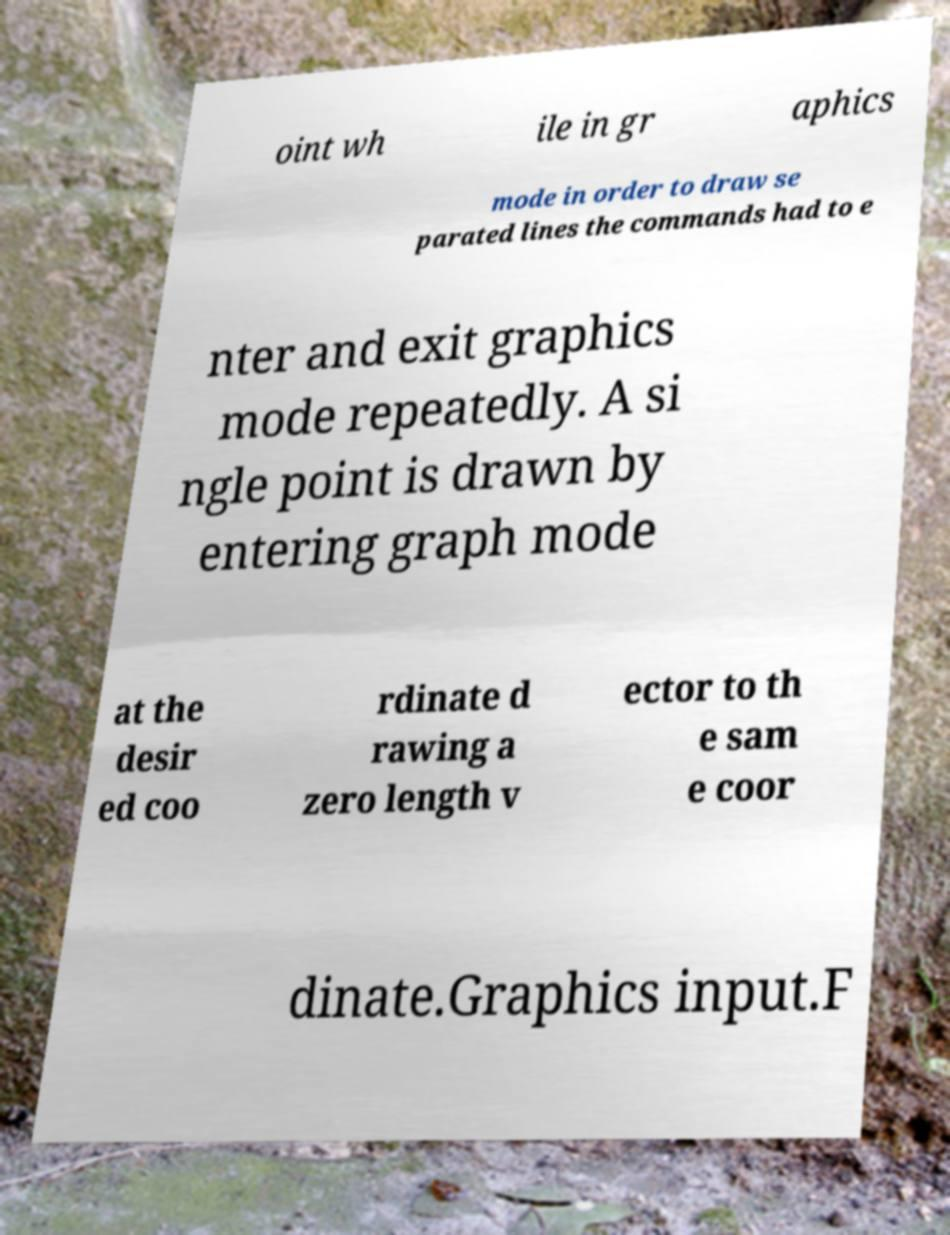I need the written content from this picture converted into text. Can you do that? oint wh ile in gr aphics mode in order to draw se parated lines the commands had to e nter and exit graphics mode repeatedly. A si ngle point is drawn by entering graph mode at the desir ed coo rdinate d rawing a zero length v ector to th e sam e coor dinate.Graphics input.F 